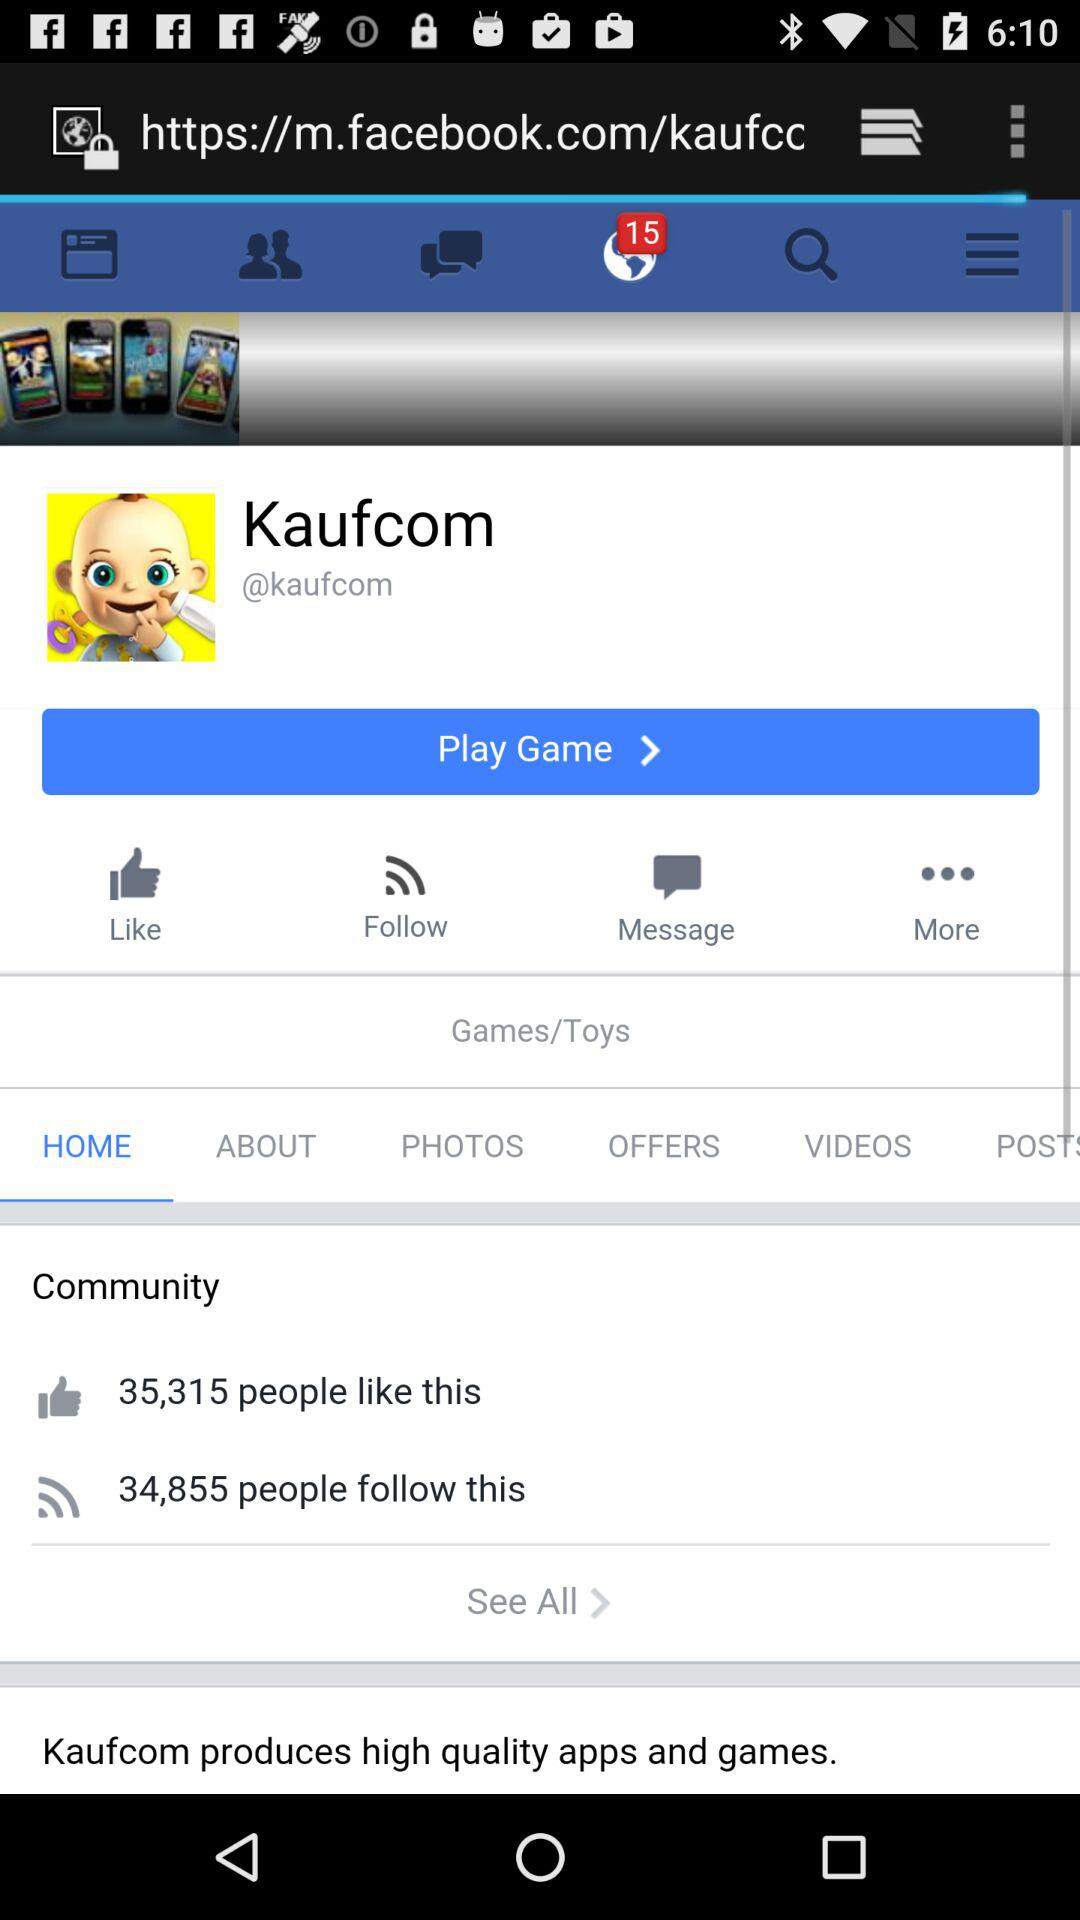How many people have liked it? It is liked by 35,315 people. 